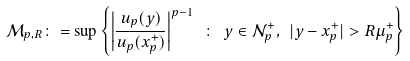<formula> <loc_0><loc_0><loc_500><loc_500>\mathcal { M } _ { p , R } \colon = \sup \left \{ \left | \frac { u _ { p } ( y ) } { u _ { p } ( x _ { p } ^ { + } ) } \right | ^ { p - 1 } \ \colon \ y \in \mathcal { N } _ { p } ^ { + } , \ | y - x _ { p } ^ { + } | > R \mu _ { p } ^ { + } \right \}</formula> 